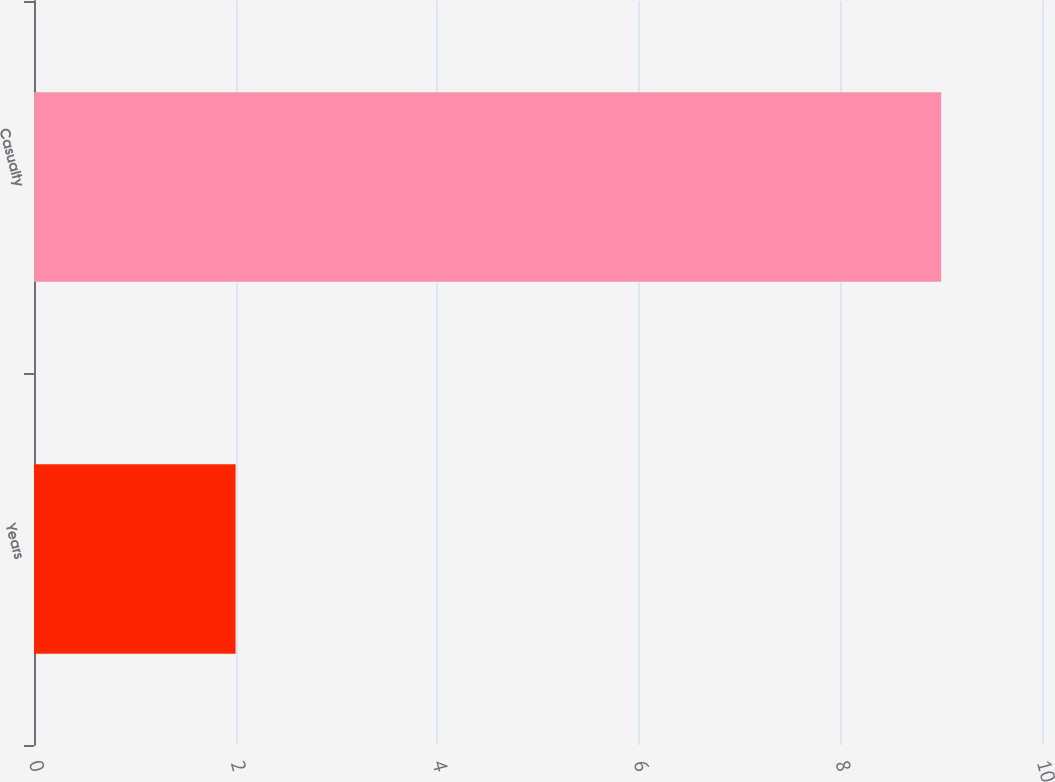Convert chart. <chart><loc_0><loc_0><loc_500><loc_500><bar_chart><fcel>Years<fcel>Casualty<nl><fcel>2<fcel>9<nl></chart> 